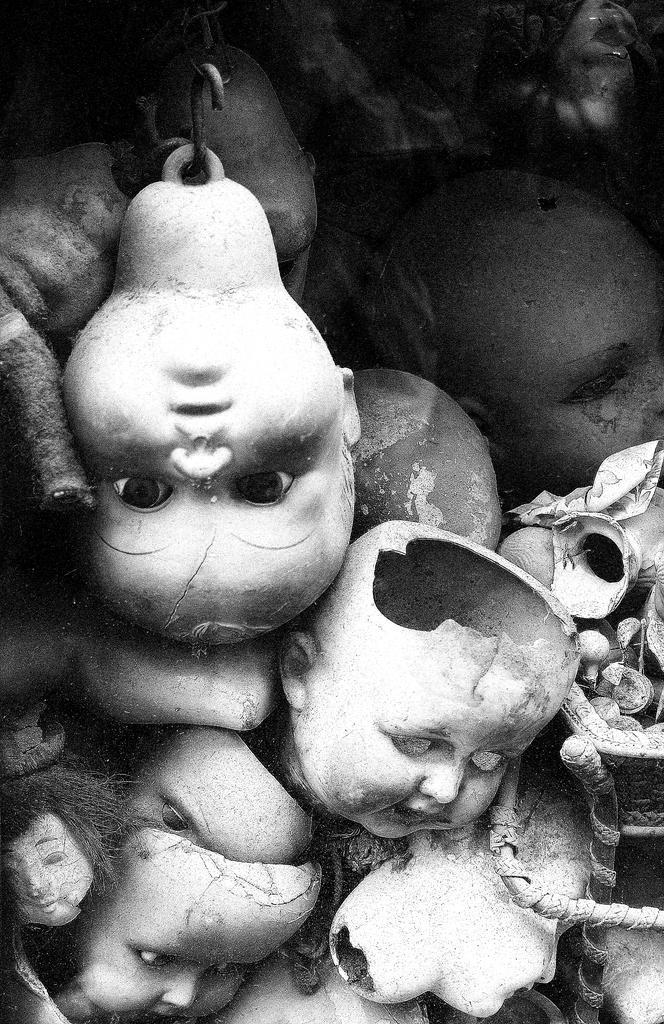Could you give a brief overview of what you see in this image? In this image I can see few toy faces and the image is in black and white. 